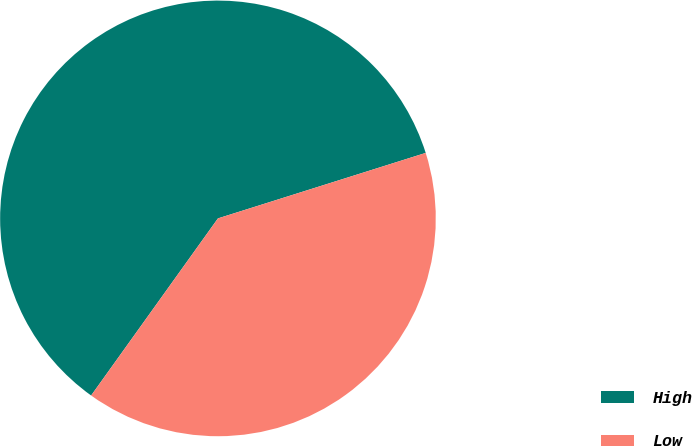Convert chart. <chart><loc_0><loc_0><loc_500><loc_500><pie_chart><fcel>High<fcel>Low<nl><fcel>60.25%<fcel>39.75%<nl></chart> 